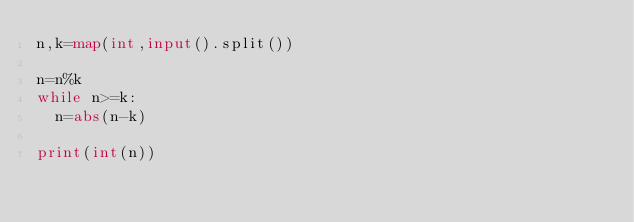Convert code to text. <code><loc_0><loc_0><loc_500><loc_500><_Python_>n,k=map(int,input().split())

n=n%k
while n>=k:
  n=abs(n-k)
  
print(int(n))</code> 